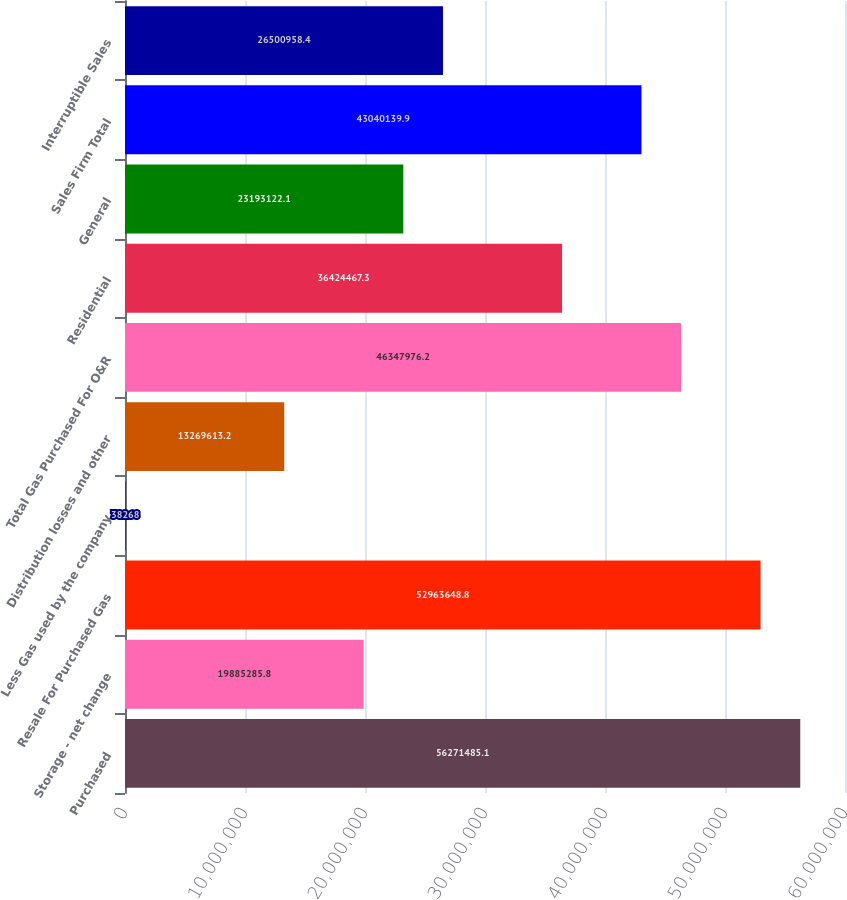<chart> <loc_0><loc_0><loc_500><loc_500><bar_chart><fcel>Purchased<fcel>Storage - net change<fcel>Resale For Purchased Gas<fcel>Less Gas used by the company<fcel>Distribution losses and other<fcel>Total Gas Purchased For O&R<fcel>Residential<fcel>General<fcel>Sales Firm Total<fcel>Interruptible Sales<nl><fcel>5.62715e+07<fcel>1.98853e+07<fcel>5.29636e+07<fcel>38268<fcel>1.32696e+07<fcel>4.6348e+07<fcel>3.64245e+07<fcel>2.31931e+07<fcel>4.30401e+07<fcel>2.6501e+07<nl></chart> 